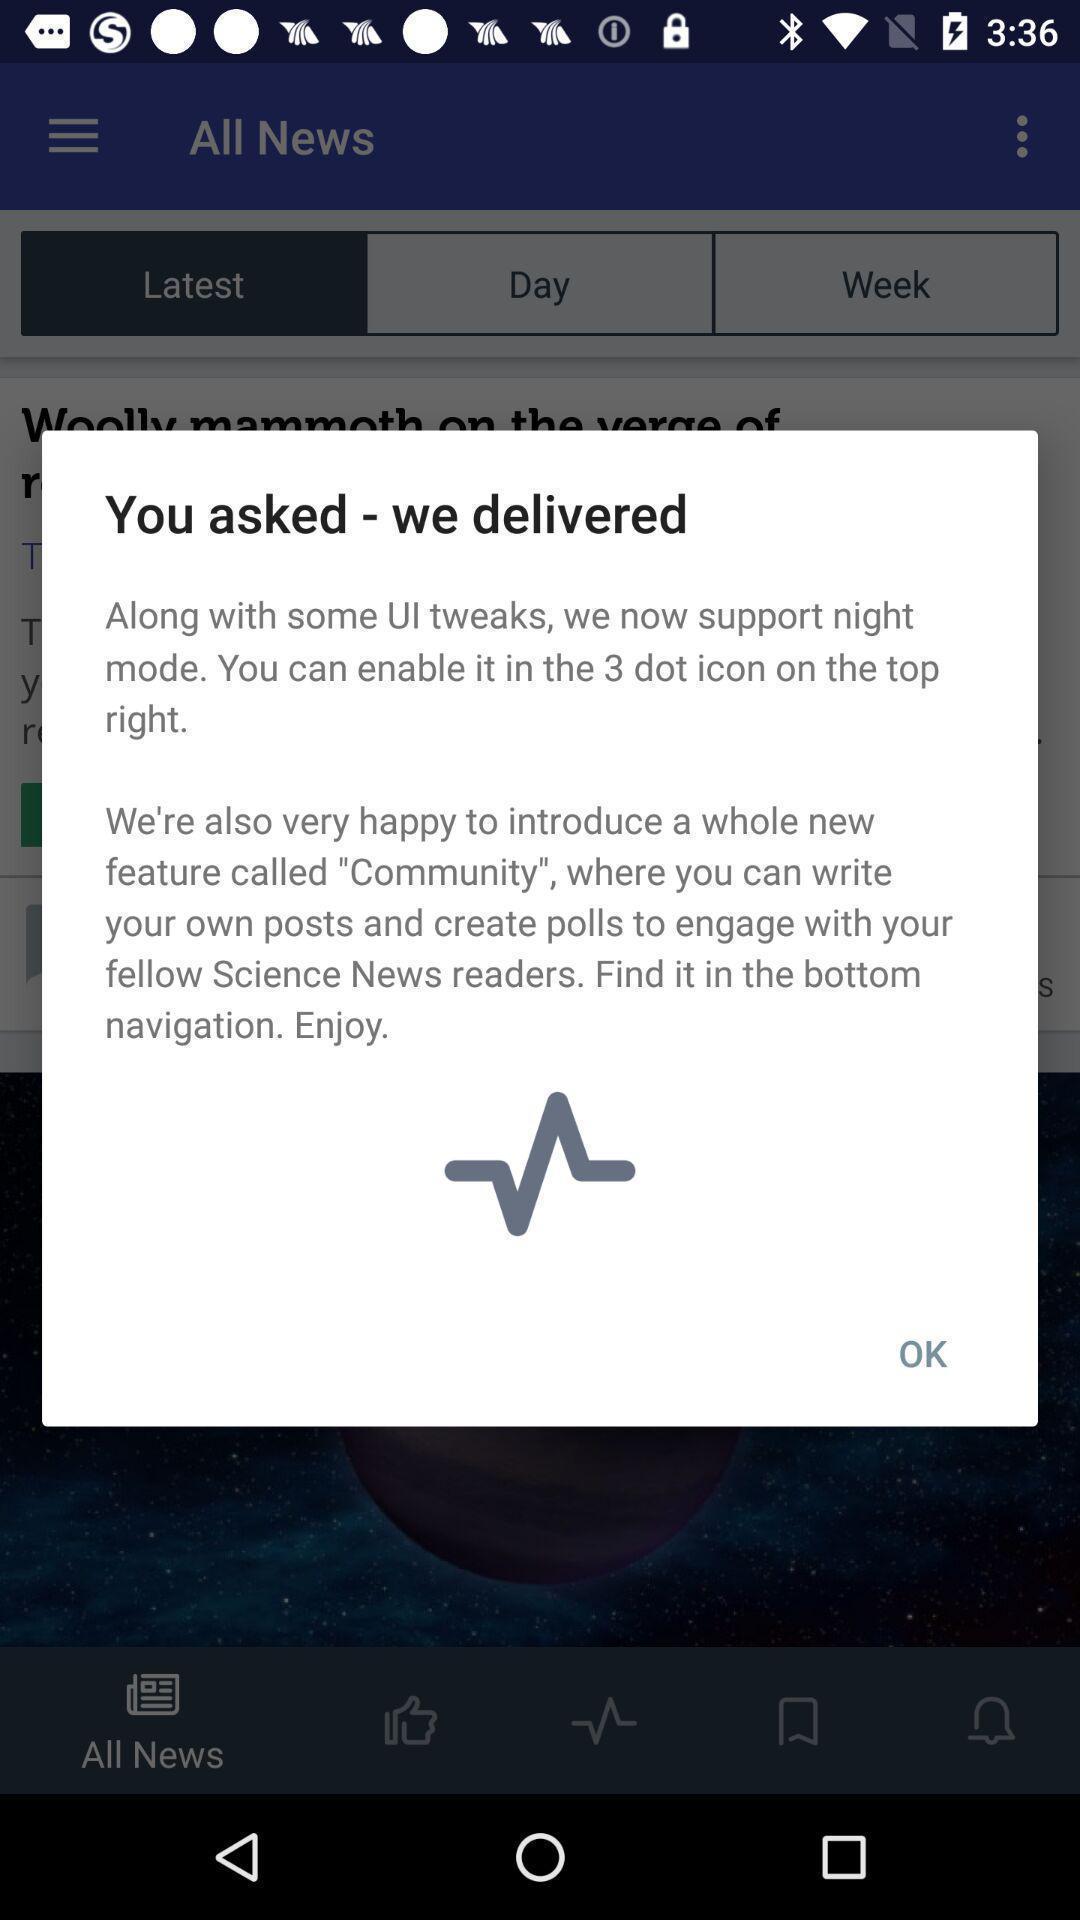What details can you identify in this image? Pop-up message with information about the application. 